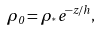Convert formula to latex. <formula><loc_0><loc_0><loc_500><loc_500>\rho _ { 0 } = \rho _ { ^ { * } } e ^ { - z / h } ,</formula> 